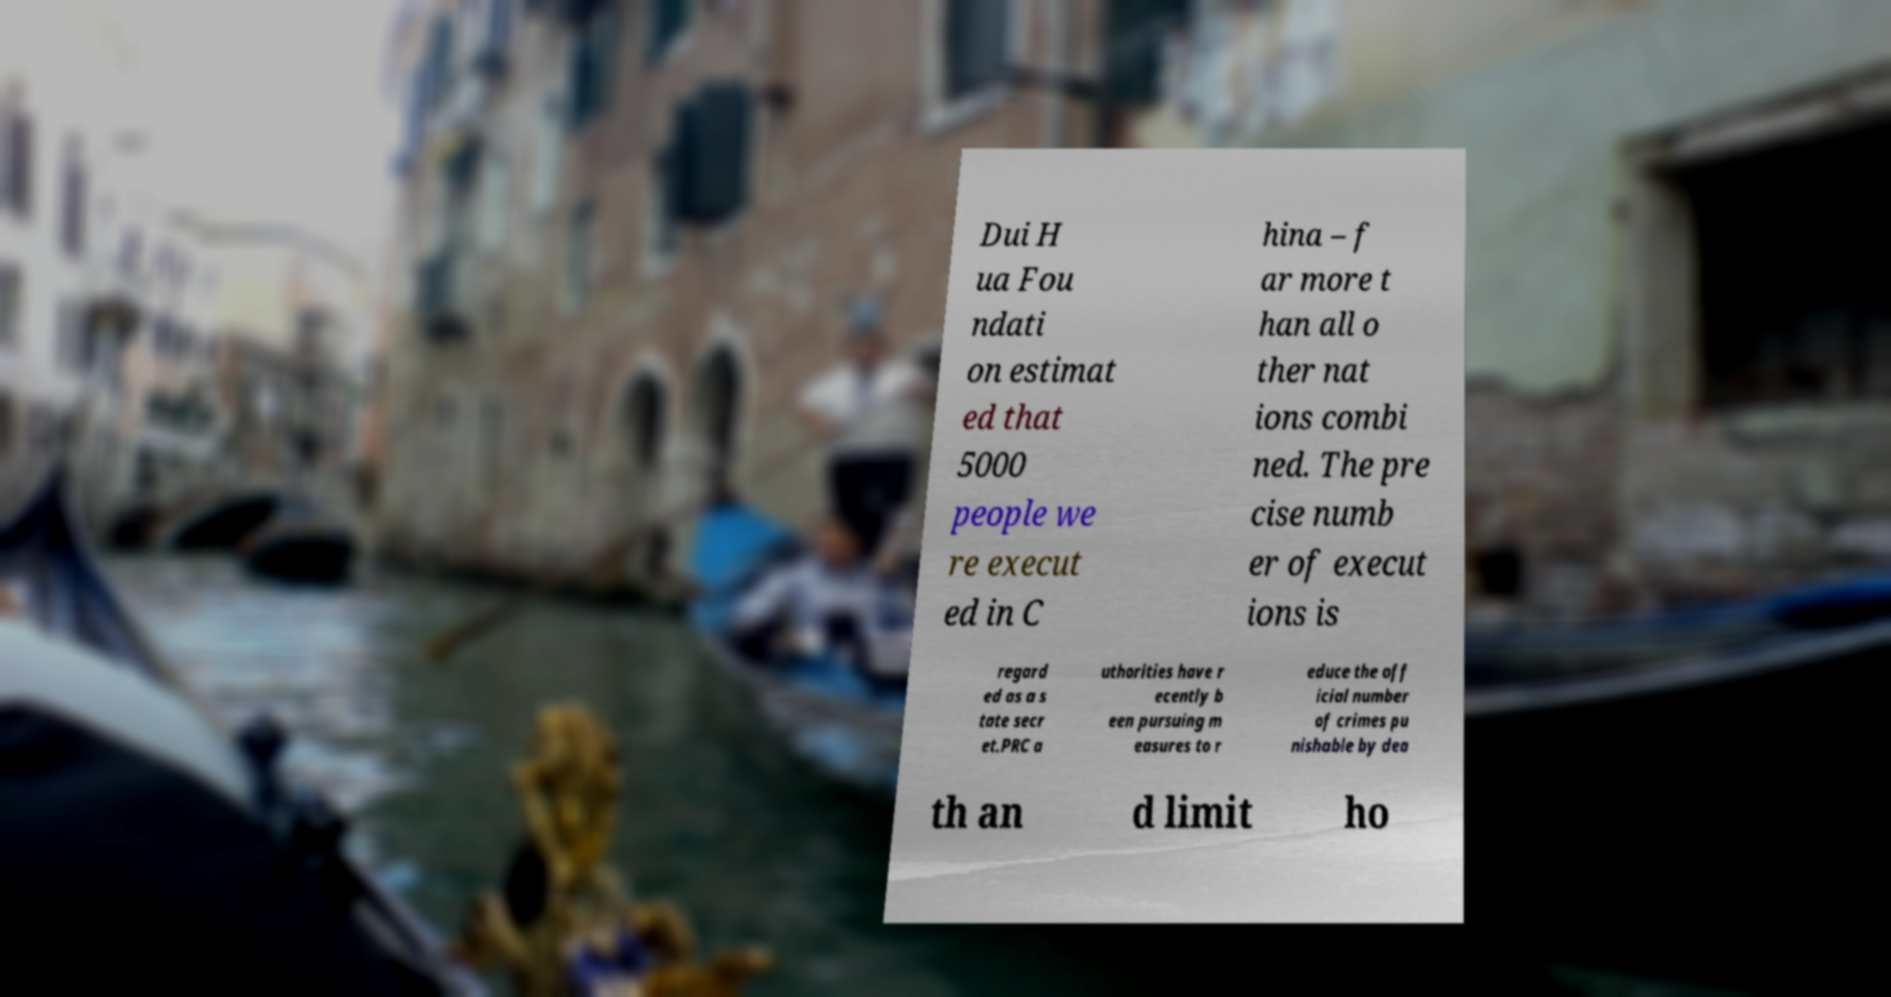Could you extract and type out the text from this image? Dui H ua Fou ndati on estimat ed that 5000 people we re execut ed in C hina – f ar more t han all o ther nat ions combi ned. The pre cise numb er of execut ions is regard ed as a s tate secr et.PRC a uthorities have r ecently b een pursuing m easures to r educe the off icial number of crimes pu nishable by dea th an d limit ho 